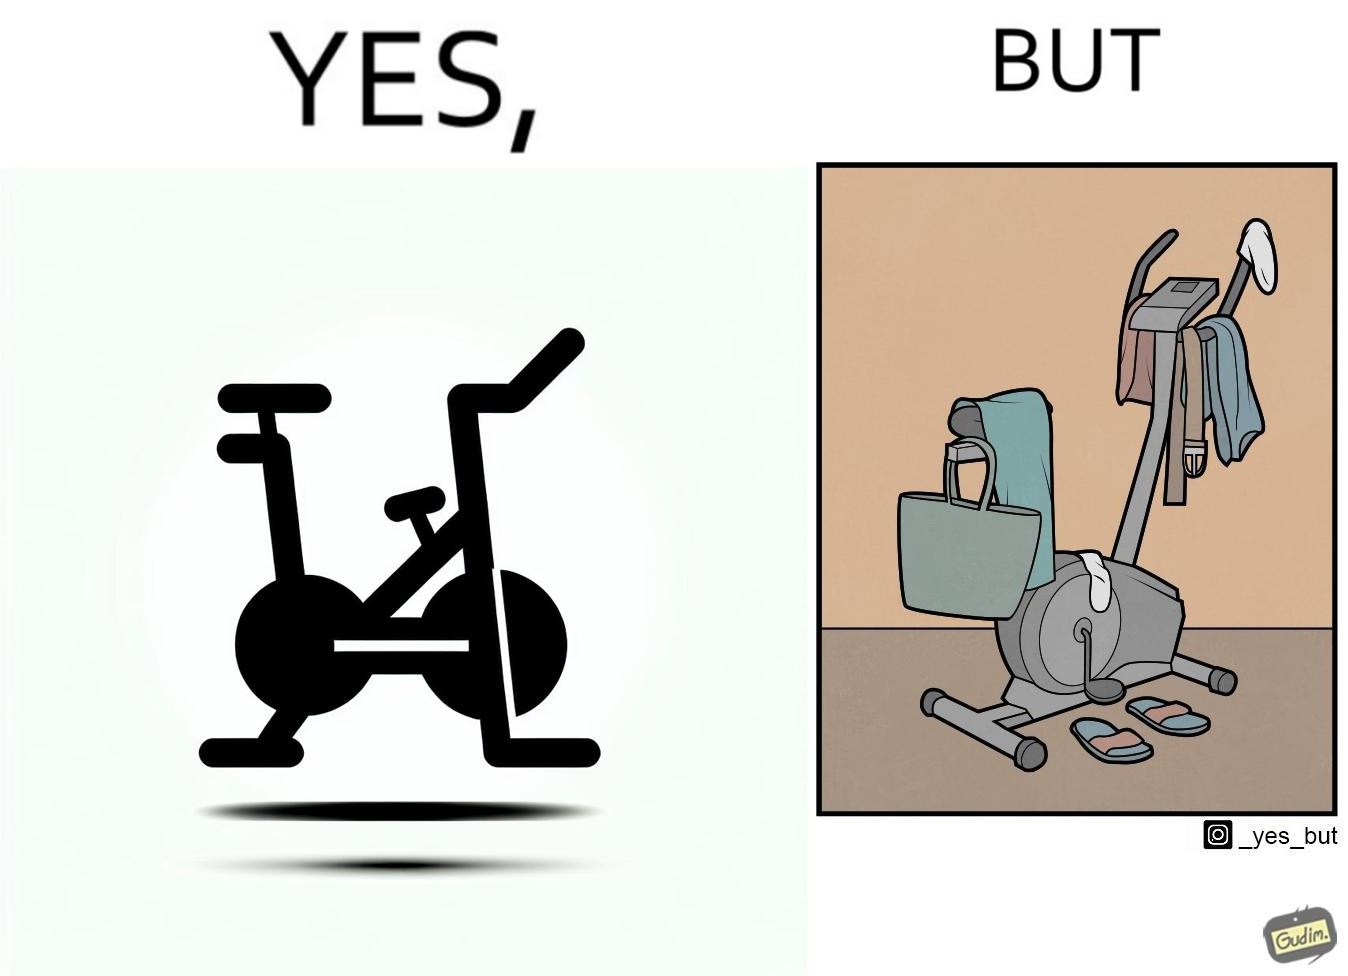Describe the contrast between the left and right parts of this image. In the left part of the image: An exercise bike In the right part of the image: An exercise bike being used to hang clothes and other items 